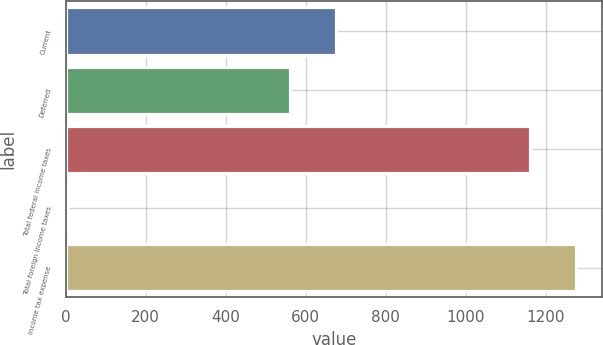<chart> <loc_0><loc_0><loc_500><loc_500><bar_chart><fcel>Current<fcel>Deferred<fcel>Total federal income taxes<fcel>Total foreign income taxes<fcel>Income tax expense<nl><fcel>677.1<fcel>561<fcel>1161<fcel>3<fcel>1277.1<nl></chart> 